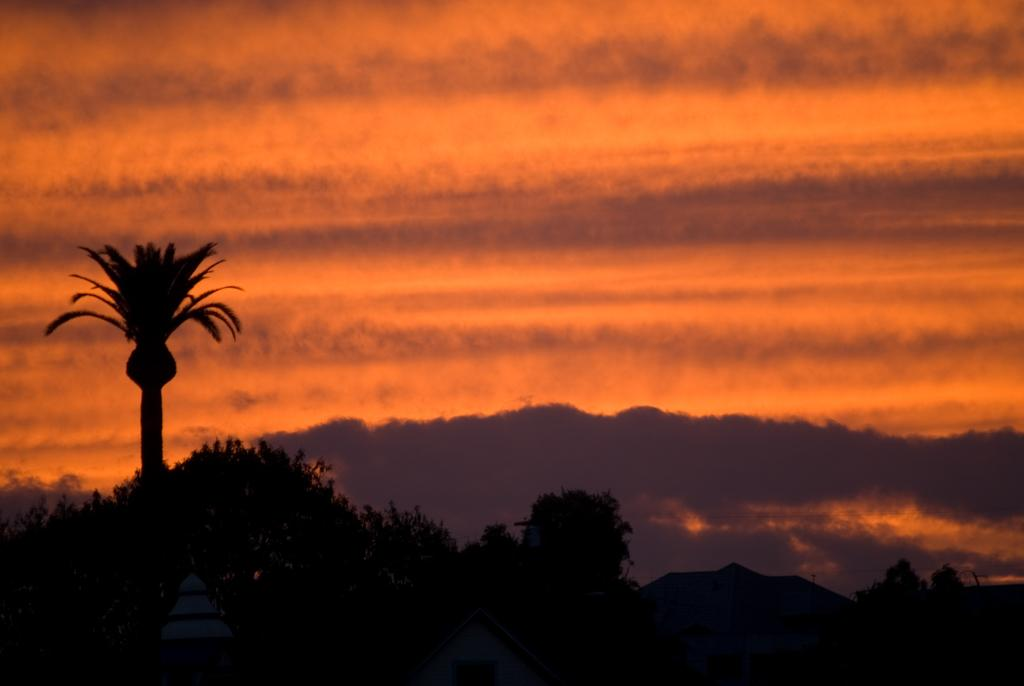What type of natural vegetation can be seen in the image? There are trees in the image. What type of structures are present in the image? There are sheds in the image. What can be seen in the distance in the image? Mountains are visible in the background of the image. What is visible above the structures and trees in the image? The sky is visible in the background of the image. Can you tell me how many tickets the maid is holding in the image? There is no maid or ticket present in the image. What type of magic is being performed by the trees in the image? There is no magic or magical activity involving the trees in the image. 